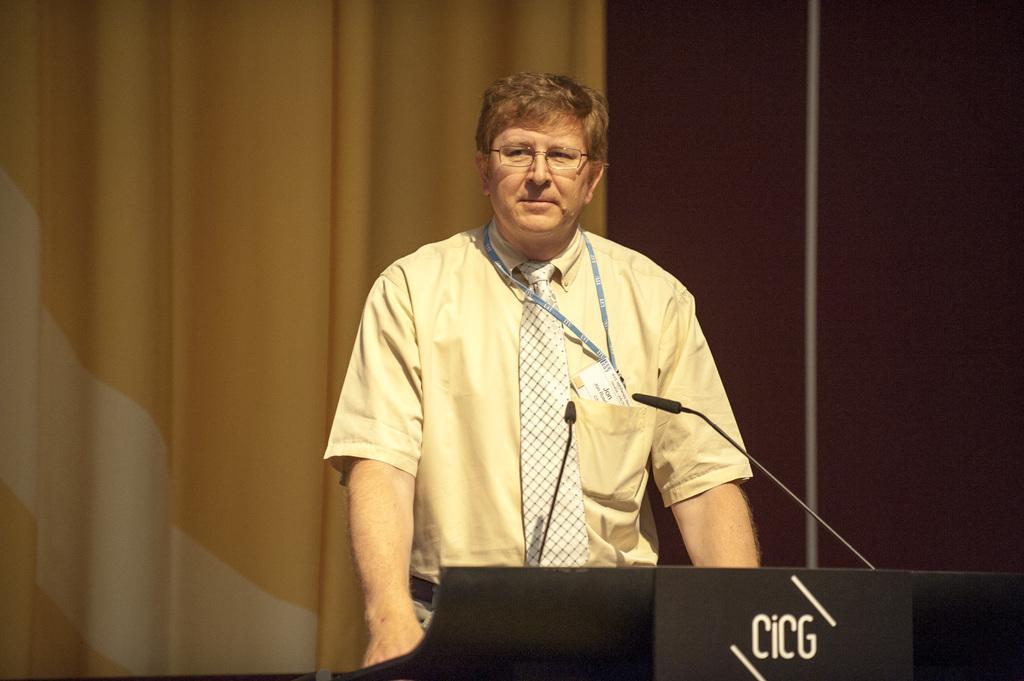Could you give a brief overview of what you see in this image? In the picture we can see a man standing near the desk, which is black in color with a microphone and the man is wearing a yellow shirt with a tie and keeping his hands in his trouser pockets and in the background we can see a curtain which is yellow in color to the wall. 